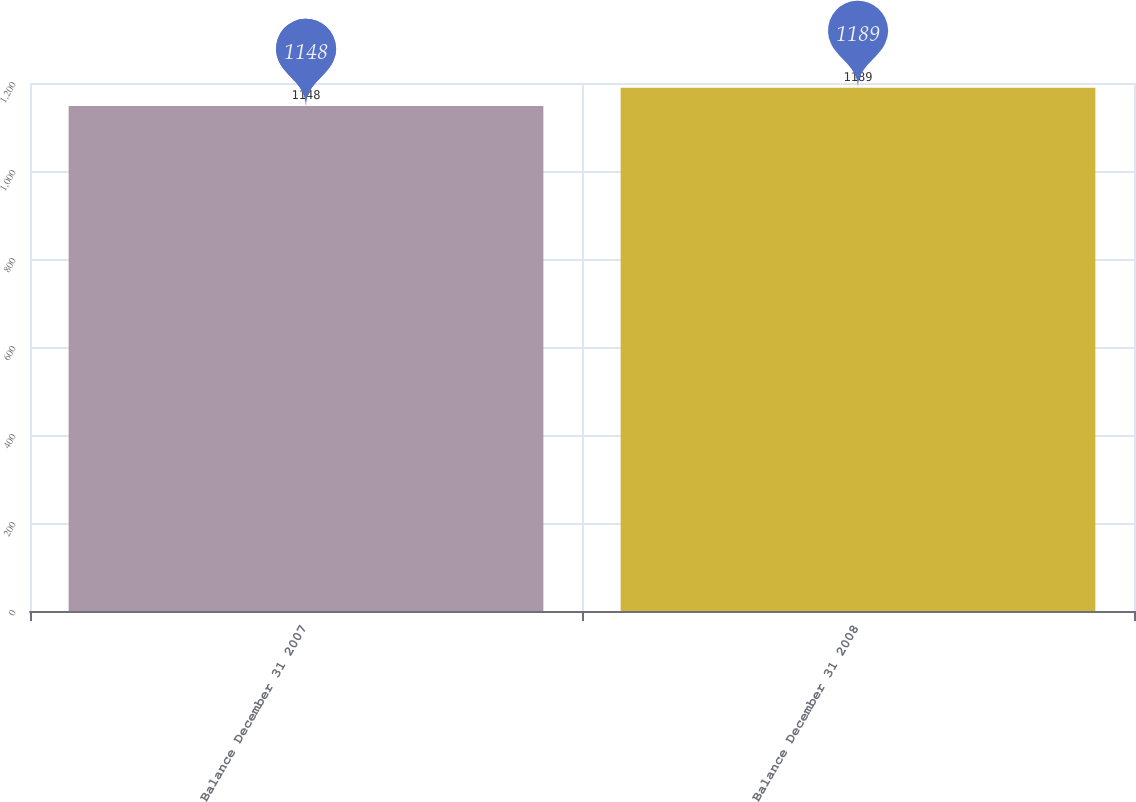Convert chart to OTSL. <chart><loc_0><loc_0><loc_500><loc_500><bar_chart><fcel>Balance December 31 2007<fcel>Balance December 31 2008<nl><fcel>1148<fcel>1189<nl></chart> 